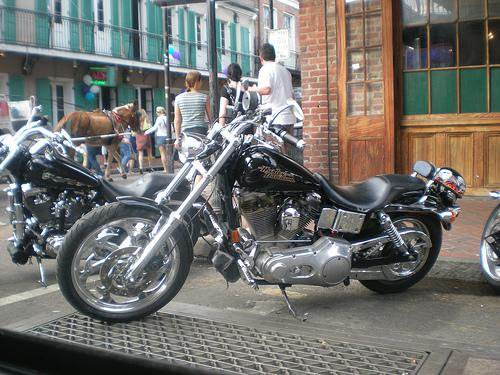Briefly describe the scene related to humans in the image. A man in a white shirt, a woman in a striped shirt, and people wearing shorts are standing on the side of the street. Mention a unique feature of the motorcycles in the image. Motorcycles with chrome detailing and orange reflector are parked on the street. What type of clothing are the people on the image wearing? A woman wearing a white and blue striped shirt and a man wearing a short-sleeved white shirt. Describe the scene involving the horse in the image. A brown pony in the background is being led by a woman wearing a striped shirt. Mention the most eye-catching detail of the brick building in the image. A brick building with wooden window frames and green shutters. What type of building is mentioned in the image and what is unique about it? A two-story building with green shutters and a neon sign on the front. Describe any animals that can be seen in the image. A brown and white horse is attached to a buggy with a woman guiding it. Provide a simple description of the main object in the image. Motorcycles parked on the street in front of a brick building. List the colors of the balloons visible in the image. Blue, purple, and white balloons are attached to a building. Describe any accessories related to the motorcycles in the image. A black and orange helmet is resting next to the taillight of a motorcycle. 